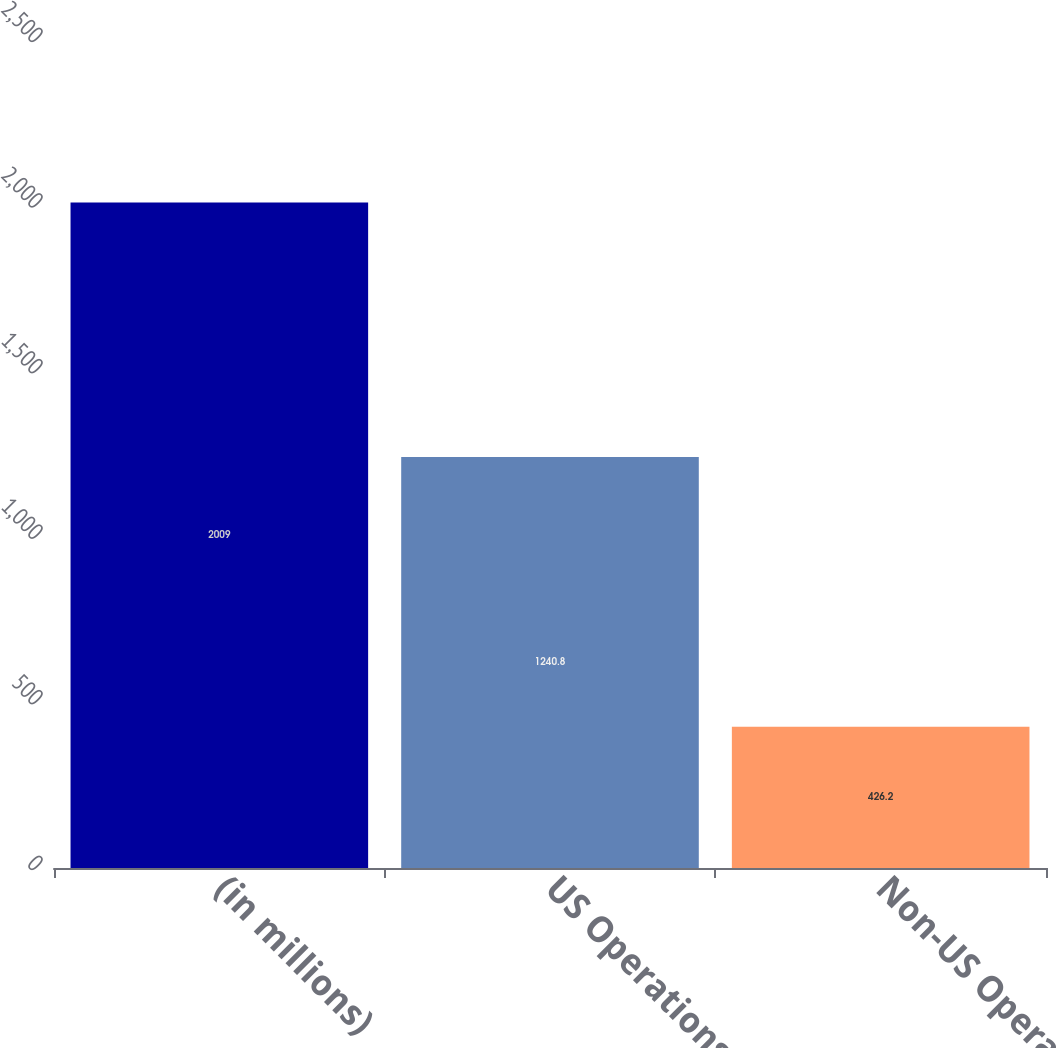Convert chart. <chart><loc_0><loc_0><loc_500><loc_500><bar_chart><fcel>(in millions)<fcel>US Operations<fcel>Non-US Operations<nl><fcel>2009<fcel>1240.8<fcel>426.2<nl></chart> 